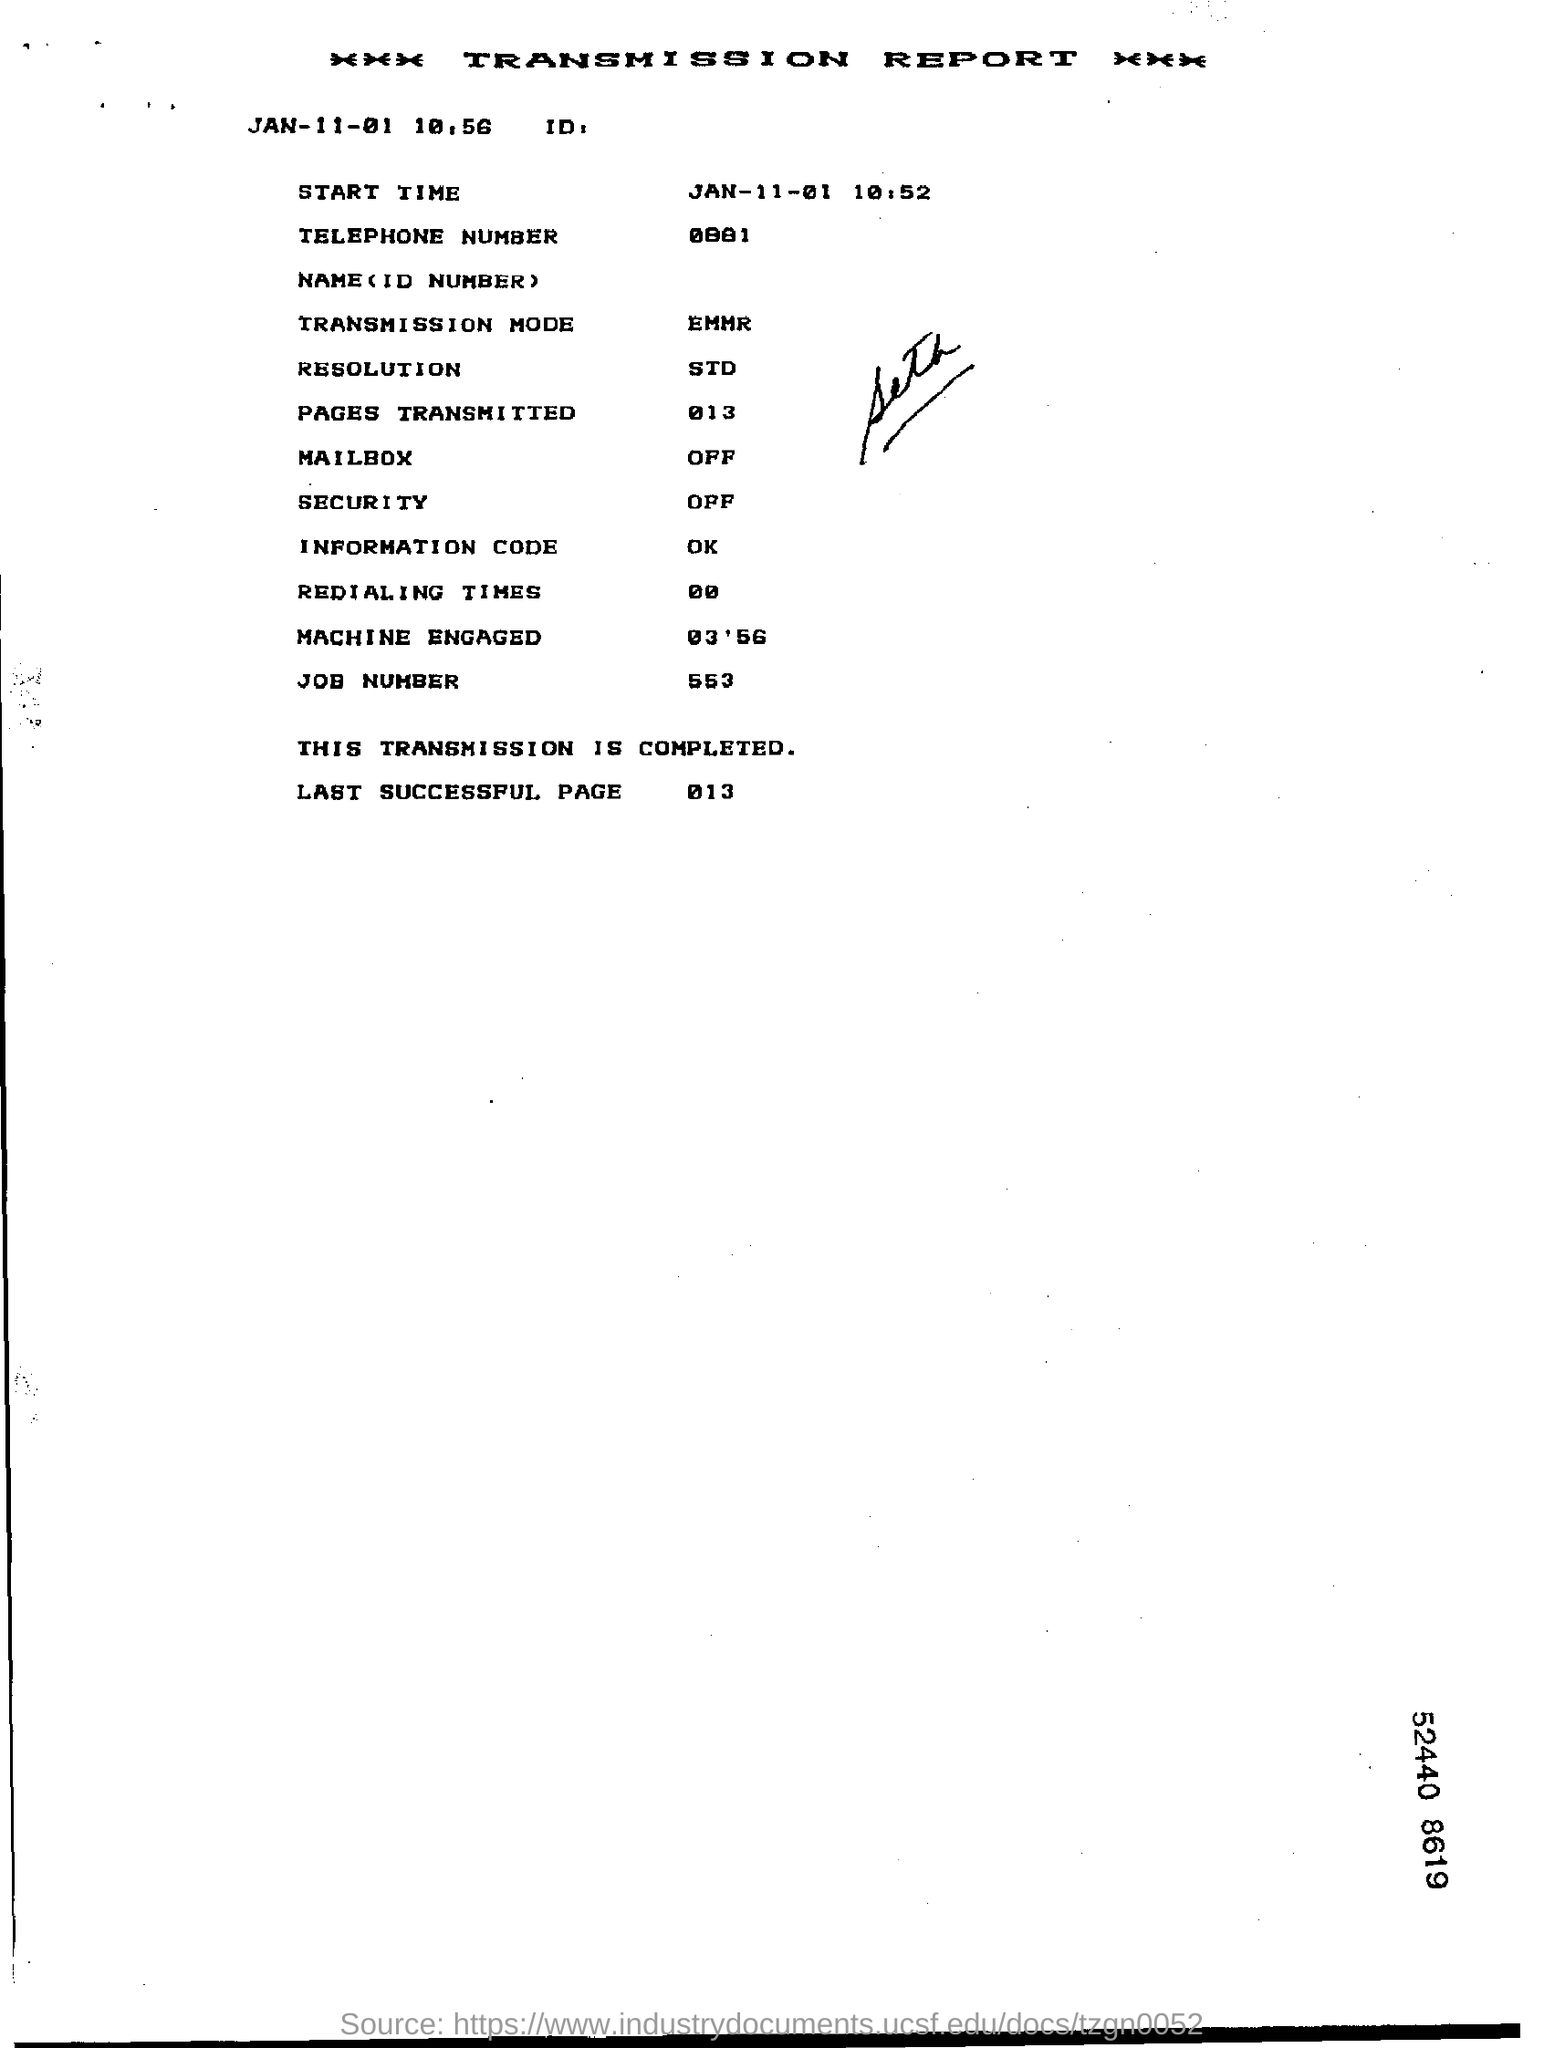What kind of the report it is?
Make the answer very short. Transmission report. What is the transmission mode?
Ensure brevity in your answer.  EMMR. What is the resolution?
Provide a succinct answer. STD. What is the job number?
Offer a very short reply. 553. What is the last successful page?
Your response must be concise. 013. What is the information code?
Offer a terse response. OK. 